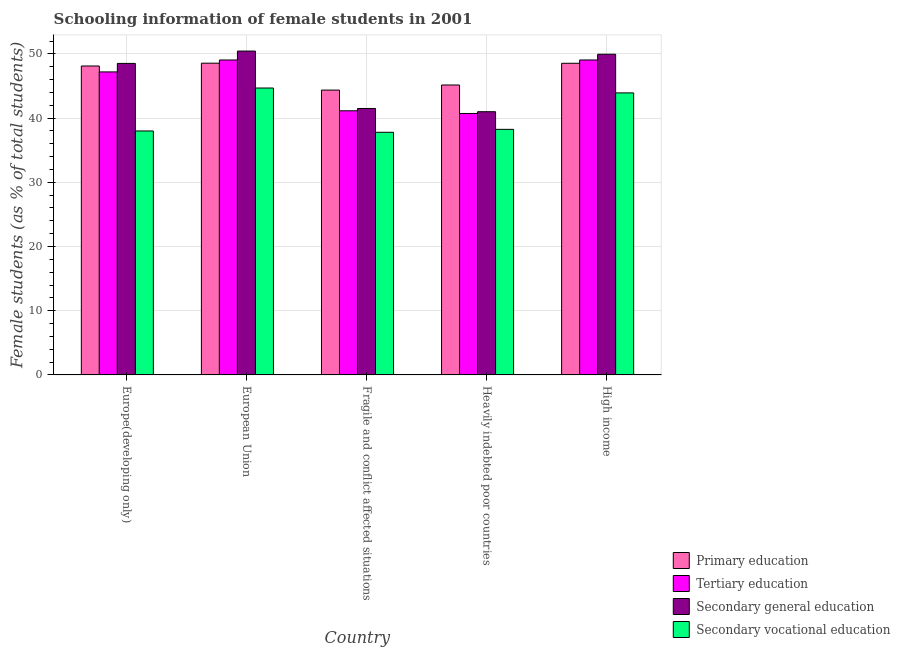How many groups of bars are there?
Keep it short and to the point. 5. Are the number of bars per tick equal to the number of legend labels?
Ensure brevity in your answer.  Yes. How many bars are there on the 1st tick from the left?
Offer a terse response. 4. How many bars are there on the 1st tick from the right?
Offer a terse response. 4. What is the label of the 1st group of bars from the left?
Your answer should be compact. Europe(developing only). In how many cases, is the number of bars for a given country not equal to the number of legend labels?
Make the answer very short. 0. What is the percentage of female students in tertiary education in High income?
Provide a succinct answer. 49.05. Across all countries, what is the maximum percentage of female students in primary education?
Ensure brevity in your answer.  48.55. Across all countries, what is the minimum percentage of female students in secondary vocational education?
Your answer should be very brief. 37.78. In which country was the percentage of female students in secondary vocational education maximum?
Your response must be concise. European Union. In which country was the percentage of female students in secondary vocational education minimum?
Your answer should be compact. Fragile and conflict affected situations. What is the total percentage of female students in secondary education in the graph?
Give a very brief answer. 231.37. What is the difference between the percentage of female students in secondary vocational education in Fragile and conflict affected situations and that in Heavily indebted poor countries?
Your answer should be compact. -0.46. What is the difference between the percentage of female students in tertiary education in Fragile and conflict affected situations and the percentage of female students in primary education in Europe(developing only)?
Make the answer very short. -6.98. What is the average percentage of female students in secondary education per country?
Your answer should be very brief. 46.27. What is the difference between the percentage of female students in tertiary education and percentage of female students in primary education in Heavily indebted poor countries?
Provide a short and direct response. -4.43. What is the ratio of the percentage of female students in secondary vocational education in Fragile and conflict affected situations to that in Heavily indebted poor countries?
Your answer should be very brief. 0.99. What is the difference between the highest and the second highest percentage of female students in primary education?
Give a very brief answer. 0.02. What is the difference between the highest and the lowest percentage of female students in tertiary education?
Provide a succinct answer. 8.33. In how many countries, is the percentage of female students in secondary education greater than the average percentage of female students in secondary education taken over all countries?
Make the answer very short. 3. What does the 4th bar from the left in Europe(developing only) represents?
Offer a terse response. Secondary vocational education. What does the 3rd bar from the right in European Union represents?
Provide a succinct answer. Tertiary education. How many countries are there in the graph?
Offer a terse response. 5. What is the difference between two consecutive major ticks on the Y-axis?
Your response must be concise. 10. How many legend labels are there?
Offer a terse response. 4. How are the legend labels stacked?
Give a very brief answer. Vertical. What is the title of the graph?
Provide a succinct answer. Schooling information of female students in 2001. What is the label or title of the X-axis?
Your answer should be compact. Country. What is the label or title of the Y-axis?
Offer a very short reply. Female students (as % of total students). What is the Female students (as % of total students) in Primary education in Europe(developing only)?
Your response must be concise. 48.11. What is the Female students (as % of total students) of Tertiary education in Europe(developing only)?
Your answer should be compact. 47.19. What is the Female students (as % of total students) in Secondary general education in Europe(developing only)?
Offer a terse response. 48.51. What is the Female students (as % of total students) of Secondary vocational education in Europe(developing only)?
Keep it short and to the point. 37.99. What is the Female students (as % of total students) in Primary education in European Union?
Give a very brief answer. 48.55. What is the Female students (as % of total students) of Tertiary education in European Union?
Your answer should be compact. 49.04. What is the Female students (as % of total students) of Secondary general education in European Union?
Provide a short and direct response. 50.43. What is the Female students (as % of total students) in Secondary vocational education in European Union?
Your answer should be compact. 44.68. What is the Female students (as % of total students) in Primary education in Fragile and conflict affected situations?
Offer a very short reply. 44.36. What is the Female students (as % of total students) in Tertiary education in Fragile and conflict affected situations?
Provide a succinct answer. 41.13. What is the Female students (as % of total students) of Secondary general education in Fragile and conflict affected situations?
Your answer should be very brief. 41.49. What is the Female students (as % of total students) of Secondary vocational education in Fragile and conflict affected situations?
Your response must be concise. 37.78. What is the Female students (as % of total students) of Primary education in Heavily indebted poor countries?
Offer a terse response. 45.15. What is the Female students (as % of total students) of Tertiary education in Heavily indebted poor countries?
Your response must be concise. 40.71. What is the Female students (as % of total students) in Secondary general education in Heavily indebted poor countries?
Your answer should be very brief. 40.99. What is the Female students (as % of total students) in Secondary vocational education in Heavily indebted poor countries?
Give a very brief answer. 38.24. What is the Female students (as % of total students) in Primary education in High income?
Keep it short and to the point. 48.53. What is the Female students (as % of total students) of Tertiary education in High income?
Ensure brevity in your answer.  49.05. What is the Female students (as % of total students) in Secondary general education in High income?
Your answer should be very brief. 49.94. What is the Female students (as % of total students) of Secondary vocational education in High income?
Your response must be concise. 43.92. Across all countries, what is the maximum Female students (as % of total students) of Primary education?
Offer a terse response. 48.55. Across all countries, what is the maximum Female students (as % of total students) in Tertiary education?
Your answer should be very brief. 49.05. Across all countries, what is the maximum Female students (as % of total students) of Secondary general education?
Provide a succinct answer. 50.43. Across all countries, what is the maximum Female students (as % of total students) in Secondary vocational education?
Give a very brief answer. 44.68. Across all countries, what is the minimum Female students (as % of total students) of Primary education?
Ensure brevity in your answer.  44.36. Across all countries, what is the minimum Female students (as % of total students) in Tertiary education?
Provide a succinct answer. 40.71. Across all countries, what is the minimum Female students (as % of total students) in Secondary general education?
Keep it short and to the point. 40.99. Across all countries, what is the minimum Female students (as % of total students) of Secondary vocational education?
Provide a succinct answer. 37.78. What is the total Female students (as % of total students) in Primary education in the graph?
Your response must be concise. 234.69. What is the total Female students (as % of total students) in Tertiary education in the graph?
Give a very brief answer. 227.12. What is the total Female students (as % of total students) of Secondary general education in the graph?
Ensure brevity in your answer.  231.37. What is the total Female students (as % of total students) in Secondary vocational education in the graph?
Your answer should be compact. 202.61. What is the difference between the Female students (as % of total students) of Primary education in Europe(developing only) and that in European Union?
Ensure brevity in your answer.  -0.44. What is the difference between the Female students (as % of total students) in Tertiary education in Europe(developing only) and that in European Union?
Give a very brief answer. -1.86. What is the difference between the Female students (as % of total students) in Secondary general education in Europe(developing only) and that in European Union?
Keep it short and to the point. -1.92. What is the difference between the Female students (as % of total students) in Secondary vocational education in Europe(developing only) and that in European Union?
Your response must be concise. -6.69. What is the difference between the Female students (as % of total students) in Primary education in Europe(developing only) and that in Fragile and conflict affected situations?
Keep it short and to the point. 3.75. What is the difference between the Female students (as % of total students) in Tertiary education in Europe(developing only) and that in Fragile and conflict affected situations?
Provide a short and direct response. 6.05. What is the difference between the Female students (as % of total students) in Secondary general education in Europe(developing only) and that in Fragile and conflict affected situations?
Keep it short and to the point. 7.02. What is the difference between the Female students (as % of total students) in Secondary vocational education in Europe(developing only) and that in Fragile and conflict affected situations?
Offer a terse response. 0.21. What is the difference between the Female students (as % of total students) of Primary education in Europe(developing only) and that in Heavily indebted poor countries?
Your answer should be very brief. 2.96. What is the difference between the Female students (as % of total students) of Tertiary education in Europe(developing only) and that in Heavily indebted poor countries?
Provide a succinct answer. 6.47. What is the difference between the Female students (as % of total students) of Secondary general education in Europe(developing only) and that in Heavily indebted poor countries?
Keep it short and to the point. 7.52. What is the difference between the Female students (as % of total students) of Secondary vocational education in Europe(developing only) and that in Heavily indebted poor countries?
Your answer should be very brief. -0.25. What is the difference between the Female students (as % of total students) in Primary education in Europe(developing only) and that in High income?
Your answer should be compact. -0.42. What is the difference between the Female students (as % of total students) in Tertiary education in Europe(developing only) and that in High income?
Provide a succinct answer. -1.86. What is the difference between the Female students (as % of total students) in Secondary general education in Europe(developing only) and that in High income?
Make the answer very short. -1.43. What is the difference between the Female students (as % of total students) of Secondary vocational education in Europe(developing only) and that in High income?
Your answer should be very brief. -5.93. What is the difference between the Female students (as % of total students) of Primary education in European Union and that in Fragile and conflict affected situations?
Ensure brevity in your answer.  4.19. What is the difference between the Female students (as % of total students) of Tertiary education in European Union and that in Fragile and conflict affected situations?
Provide a short and direct response. 7.91. What is the difference between the Female students (as % of total students) in Secondary general education in European Union and that in Fragile and conflict affected situations?
Offer a very short reply. 8.94. What is the difference between the Female students (as % of total students) of Secondary vocational education in European Union and that in Fragile and conflict affected situations?
Provide a short and direct response. 6.89. What is the difference between the Female students (as % of total students) in Primary education in European Union and that in Heavily indebted poor countries?
Your response must be concise. 3.4. What is the difference between the Female students (as % of total students) of Tertiary education in European Union and that in Heavily indebted poor countries?
Offer a terse response. 8.33. What is the difference between the Female students (as % of total students) of Secondary general education in European Union and that in Heavily indebted poor countries?
Provide a succinct answer. 9.44. What is the difference between the Female students (as % of total students) of Secondary vocational education in European Union and that in Heavily indebted poor countries?
Offer a terse response. 6.44. What is the difference between the Female students (as % of total students) in Primary education in European Union and that in High income?
Your response must be concise. 0.02. What is the difference between the Female students (as % of total students) of Tertiary education in European Union and that in High income?
Provide a succinct answer. -0. What is the difference between the Female students (as % of total students) of Secondary general education in European Union and that in High income?
Your response must be concise. 0.49. What is the difference between the Female students (as % of total students) of Secondary vocational education in European Union and that in High income?
Offer a terse response. 0.76. What is the difference between the Female students (as % of total students) of Primary education in Fragile and conflict affected situations and that in Heavily indebted poor countries?
Give a very brief answer. -0.79. What is the difference between the Female students (as % of total students) in Tertiary education in Fragile and conflict affected situations and that in Heavily indebted poor countries?
Make the answer very short. 0.42. What is the difference between the Female students (as % of total students) in Secondary general education in Fragile and conflict affected situations and that in Heavily indebted poor countries?
Provide a short and direct response. 0.5. What is the difference between the Female students (as % of total students) of Secondary vocational education in Fragile and conflict affected situations and that in Heavily indebted poor countries?
Your answer should be compact. -0.46. What is the difference between the Female students (as % of total students) in Primary education in Fragile and conflict affected situations and that in High income?
Provide a short and direct response. -4.17. What is the difference between the Female students (as % of total students) in Tertiary education in Fragile and conflict affected situations and that in High income?
Offer a terse response. -7.91. What is the difference between the Female students (as % of total students) of Secondary general education in Fragile and conflict affected situations and that in High income?
Offer a terse response. -8.45. What is the difference between the Female students (as % of total students) of Secondary vocational education in Fragile and conflict affected situations and that in High income?
Provide a short and direct response. -6.13. What is the difference between the Female students (as % of total students) of Primary education in Heavily indebted poor countries and that in High income?
Provide a succinct answer. -3.38. What is the difference between the Female students (as % of total students) in Tertiary education in Heavily indebted poor countries and that in High income?
Offer a very short reply. -8.33. What is the difference between the Female students (as % of total students) of Secondary general education in Heavily indebted poor countries and that in High income?
Make the answer very short. -8.95. What is the difference between the Female students (as % of total students) of Secondary vocational education in Heavily indebted poor countries and that in High income?
Give a very brief answer. -5.68. What is the difference between the Female students (as % of total students) in Primary education in Europe(developing only) and the Female students (as % of total students) in Tertiary education in European Union?
Offer a very short reply. -0.93. What is the difference between the Female students (as % of total students) of Primary education in Europe(developing only) and the Female students (as % of total students) of Secondary general education in European Union?
Keep it short and to the point. -2.32. What is the difference between the Female students (as % of total students) in Primary education in Europe(developing only) and the Female students (as % of total students) in Secondary vocational education in European Union?
Your response must be concise. 3.43. What is the difference between the Female students (as % of total students) in Tertiary education in Europe(developing only) and the Female students (as % of total students) in Secondary general education in European Union?
Provide a short and direct response. -3.25. What is the difference between the Female students (as % of total students) in Tertiary education in Europe(developing only) and the Female students (as % of total students) in Secondary vocational education in European Union?
Make the answer very short. 2.51. What is the difference between the Female students (as % of total students) of Secondary general education in Europe(developing only) and the Female students (as % of total students) of Secondary vocational education in European Union?
Provide a short and direct response. 3.83. What is the difference between the Female students (as % of total students) in Primary education in Europe(developing only) and the Female students (as % of total students) in Tertiary education in Fragile and conflict affected situations?
Your response must be concise. 6.98. What is the difference between the Female students (as % of total students) in Primary education in Europe(developing only) and the Female students (as % of total students) in Secondary general education in Fragile and conflict affected situations?
Provide a short and direct response. 6.62. What is the difference between the Female students (as % of total students) in Primary education in Europe(developing only) and the Female students (as % of total students) in Secondary vocational education in Fragile and conflict affected situations?
Keep it short and to the point. 10.32. What is the difference between the Female students (as % of total students) in Tertiary education in Europe(developing only) and the Female students (as % of total students) in Secondary general education in Fragile and conflict affected situations?
Your response must be concise. 5.69. What is the difference between the Female students (as % of total students) of Tertiary education in Europe(developing only) and the Female students (as % of total students) of Secondary vocational education in Fragile and conflict affected situations?
Keep it short and to the point. 9.4. What is the difference between the Female students (as % of total students) in Secondary general education in Europe(developing only) and the Female students (as % of total students) in Secondary vocational education in Fragile and conflict affected situations?
Ensure brevity in your answer.  10.73. What is the difference between the Female students (as % of total students) of Primary education in Europe(developing only) and the Female students (as % of total students) of Tertiary education in Heavily indebted poor countries?
Your answer should be compact. 7.39. What is the difference between the Female students (as % of total students) in Primary education in Europe(developing only) and the Female students (as % of total students) in Secondary general education in Heavily indebted poor countries?
Offer a terse response. 7.12. What is the difference between the Female students (as % of total students) of Primary education in Europe(developing only) and the Female students (as % of total students) of Secondary vocational education in Heavily indebted poor countries?
Ensure brevity in your answer.  9.87. What is the difference between the Female students (as % of total students) in Tertiary education in Europe(developing only) and the Female students (as % of total students) in Secondary general education in Heavily indebted poor countries?
Your response must be concise. 6.2. What is the difference between the Female students (as % of total students) of Tertiary education in Europe(developing only) and the Female students (as % of total students) of Secondary vocational education in Heavily indebted poor countries?
Keep it short and to the point. 8.94. What is the difference between the Female students (as % of total students) of Secondary general education in Europe(developing only) and the Female students (as % of total students) of Secondary vocational education in Heavily indebted poor countries?
Provide a succinct answer. 10.27. What is the difference between the Female students (as % of total students) of Primary education in Europe(developing only) and the Female students (as % of total students) of Tertiary education in High income?
Offer a very short reply. -0.94. What is the difference between the Female students (as % of total students) of Primary education in Europe(developing only) and the Female students (as % of total students) of Secondary general education in High income?
Your response must be concise. -1.83. What is the difference between the Female students (as % of total students) of Primary education in Europe(developing only) and the Female students (as % of total students) of Secondary vocational education in High income?
Provide a succinct answer. 4.19. What is the difference between the Female students (as % of total students) in Tertiary education in Europe(developing only) and the Female students (as % of total students) in Secondary general education in High income?
Provide a short and direct response. -2.75. What is the difference between the Female students (as % of total students) of Tertiary education in Europe(developing only) and the Female students (as % of total students) of Secondary vocational education in High income?
Offer a terse response. 3.27. What is the difference between the Female students (as % of total students) in Secondary general education in Europe(developing only) and the Female students (as % of total students) in Secondary vocational education in High income?
Ensure brevity in your answer.  4.59. What is the difference between the Female students (as % of total students) of Primary education in European Union and the Female students (as % of total students) of Tertiary education in Fragile and conflict affected situations?
Your response must be concise. 7.41. What is the difference between the Female students (as % of total students) of Primary education in European Union and the Female students (as % of total students) of Secondary general education in Fragile and conflict affected situations?
Offer a terse response. 7.06. What is the difference between the Female students (as % of total students) in Primary education in European Union and the Female students (as % of total students) in Secondary vocational education in Fragile and conflict affected situations?
Provide a succinct answer. 10.76. What is the difference between the Female students (as % of total students) of Tertiary education in European Union and the Female students (as % of total students) of Secondary general education in Fragile and conflict affected situations?
Your answer should be compact. 7.55. What is the difference between the Female students (as % of total students) in Tertiary education in European Union and the Female students (as % of total students) in Secondary vocational education in Fragile and conflict affected situations?
Provide a short and direct response. 11.26. What is the difference between the Female students (as % of total students) in Secondary general education in European Union and the Female students (as % of total students) in Secondary vocational education in Fragile and conflict affected situations?
Provide a succinct answer. 12.65. What is the difference between the Female students (as % of total students) in Primary education in European Union and the Female students (as % of total students) in Tertiary education in Heavily indebted poor countries?
Your answer should be compact. 7.83. What is the difference between the Female students (as % of total students) of Primary education in European Union and the Female students (as % of total students) of Secondary general education in Heavily indebted poor countries?
Ensure brevity in your answer.  7.56. What is the difference between the Female students (as % of total students) in Primary education in European Union and the Female students (as % of total students) in Secondary vocational education in Heavily indebted poor countries?
Make the answer very short. 10.31. What is the difference between the Female students (as % of total students) of Tertiary education in European Union and the Female students (as % of total students) of Secondary general education in Heavily indebted poor countries?
Provide a short and direct response. 8.05. What is the difference between the Female students (as % of total students) in Tertiary education in European Union and the Female students (as % of total students) in Secondary vocational education in Heavily indebted poor countries?
Your answer should be compact. 10.8. What is the difference between the Female students (as % of total students) of Secondary general education in European Union and the Female students (as % of total students) of Secondary vocational education in Heavily indebted poor countries?
Provide a succinct answer. 12.19. What is the difference between the Female students (as % of total students) of Primary education in European Union and the Female students (as % of total students) of Tertiary education in High income?
Give a very brief answer. -0.5. What is the difference between the Female students (as % of total students) of Primary education in European Union and the Female students (as % of total students) of Secondary general education in High income?
Keep it short and to the point. -1.39. What is the difference between the Female students (as % of total students) in Primary education in European Union and the Female students (as % of total students) in Secondary vocational education in High income?
Your answer should be compact. 4.63. What is the difference between the Female students (as % of total students) in Tertiary education in European Union and the Female students (as % of total students) in Secondary general education in High income?
Offer a terse response. -0.9. What is the difference between the Female students (as % of total students) in Tertiary education in European Union and the Female students (as % of total students) in Secondary vocational education in High income?
Your answer should be compact. 5.12. What is the difference between the Female students (as % of total students) in Secondary general education in European Union and the Female students (as % of total students) in Secondary vocational education in High income?
Your answer should be very brief. 6.51. What is the difference between the Female students (as % of total students) in Primary education in Fragile and conflict affected situations and the Female students (as % of total students) in Tertiary education in Heavily indebted poor countries?
Provide a succinct answer. 3.64. What is the difference between the Female students (as % of total students) of Primary education in Fragile and conflict affected situations and the Female students (as % of total students) of Secondary general education in Heavily indebted poor countries?
Give a very brief answer. 3.37. What is the difference between the Female students (as % of total students) in Primary education in Fragile and conflict affected situations and the Female students (as % of total students) in Secondary vocational education in Heavily indebted poor countries?
Give a very brief answer. 6.12. What is the difference between the Female students (as % of total students) of Tertiary education in Fragile and conflict affected situations and the Female students (as % of total students) of Secondary general education in Heavily indebted poor countries?
Offer a very short reply. 0.14. What is the difference between the Female students (as % of total students) of Tertiary education in Fragile and conflict affected situations and the Female students (as % of total students) of Secondary vocational education in Heavily indebted poor countries?
Your answer should be very brief. 2.89. What is the difference between the Female students (as % of total students) of Secondary general education in Fragile and conflict affected situations and the Female students (as % of total students) of Secondary vocational education in Heavily indebted poor countries?
Your answer should be compact. 3.25. What is the difference between the Female students (as % of total students) of Primary education in Fragile and conflict affected situations and the Female students (as % of total students) of Tertiary education in High income?
Offer a terse response. -4.69. What is the difference between the Female students (as % of total students) in Primary education in Fragile and conflict affected situations and the Female students (as % of total students) in Secondary general education in High income?
Ensure brevity in your answer.  -5.58. What is the difference between the Female students (as % of total students) in Primary education in Fragile and conflict affected situations and the Female students (as % of total students) in Secondary vocational education in High income?
Offer a very short reply. 0.44. What is the difference between the Female students (as % of total students) of Tertiary education in Fragile and conflict affected situations and the Female students (as % of total students) of Secondary general education in High income?
Make the answer very short. -8.81. What is the difference between the Female students (as % of total students) in Tertiary education in Fragile and conflict affected situations and the Female students (as % of total students) in Secondary vocational education in High income?
Provide a short and direct response. -2.79. What is the difference between the Female students (as % of total students) in Secondary general education in Fragile and conflict affected situations and the Female students (as % of total students) in Secondary vocational education in High income?
Ensure brevity in your answer.  -2.43. What is the difference between the Female students (as % of total students) of Primary education in Heavily indebted poor countries and the Female students (as % of total students) of Tertiary education in High income?
Offer a very short reply. -3.9. What is the difference between the Female students (as % of total students) of Primary education in Heavily indebted poor countries and the Female students (as % of total students) of Secondary general education in High income?
Provide a succinct answer. -4.79. What is the difference between the Female students (as % of total students) in Primary education in Heavily indebted poor countries and the Female students (as % of total students) in Secondary vocational education in High income?
Ensure brevity in your answer.  1.23. What is the difference between the Female students (as % of total students) in Tertiary education in Heavily indebted poor countries and the Female students (as % of total students) in Secondary general education in High income?
Give a very brief answer. -9.23. What is the difference between the Female students (as % of total students) of Tertiary education in Heavily indebted poor countries and the Female students (as % of total students) of Secondary vocational education in High income?
Offer a terse response. -3.2. What is the difference between the Female students (as % of total students) of Secondary general education in Heavily indebted poor countries and the Female students (as % of total students) of Secondary vocational education in High income?
Make the answer very short. -2.93. What is the average Female students (as % of total students) in Primary education per country?
Offer a very short reply. 46.94. What is the average Female students (as % of total students) in Tertiary education per country?
Offer a very short reply. 45.42. What is the average Female students (as % of total students) of Secondary general education per country?
Your response must be concise. 46.27. What is the average Female students (as % of total students) in Secondary vocational education per country?
Make the answer very short. 40.52. What is the difference between the Female students (as % of total students) in Primary education and Female students (as % of total students) in Tertiary education in Europe(developing only)?
Provide a succinct answer. 0.92. What is the difference between the Female students (as % of total students) of Primary education and Female students (as % of total students) of Secondary general education in Europe(developing only)?
Keep it short and to the point. -0.4. What is the difference between the Female students (as % of total students) of Primary education and Female students (as % of total students) of Secondary vocational education in Europe(developing only)?
Your answer should be compact. 10.12. What is the difference between the Female students (as % of total students) in Tertiary education and Female students (as % of total students) in Secondary general education in Europe(developing only)?
Your response must be concise. -1.33. What is the difference between the Female students (as % of total students) in Tertiary education and Female students (as % of total students) in Secondary vocational education in Europe(developing only)?
Keep it short and to the point. 9.2. What is the difference between the Female students (as % of total students) in Secondary general education and Female students (as % of total students) in Secondary vocational education in Europe(developing only)?
Give a very brief answer. 10.52. What is the difference between the Female students (as % of total students) in Primary education and Female students (as % of total students) in Tertiary education in European Union?
Ensure brevity in your answer.  -0.5. What is the difference between the Female students (as % of total students) of Primary education and Female students (as % of total students) of Secondary general education in European Union?
Keep it short and to the point. -1.89. What is the difference between the Female students (as % of total students) of Primary education and Female students (as % of total students) of Secondary vocational education in European Union?
Make the answer very short. 3.87. What is the difference between the Female students (as % of total students) in Tertiary education and Female students (as % of total students) in Secondary general education in European Union?
Give a very brief answer. -1.39. What is the difference between the Female students (as % of total students) in Tertiary education and Female students (as % of total students) in Secondary vocational education in European Union?
Your answer should be compact. 4.37. What is the difference between the Female students (as % of total students) of Secondary general education and Female students (as % of total students) of Secondary vocational education in European Union?
Offer a very short reply. 5.76. What is the difference between the Female students (as % of total students) in Primary education and Female students (as % of total students) in Tertiary education in Fragile and conflict affected situations?
Give a very brief answer. 3.22. What is the difference between the Female students (as % of total students) in Primary education and Female students (as % of total students) in Secondary general education in Fragile and conflict affected situations?
Offer a terse response. 2.87. What is the difference between the Female students (as % of total students) in Primary education and Female students (as % of total students) in Secondary vocational education in Fragile and conflict affected situations?
Keep it short and to the point. 6.57. What is the difference between the Female students (as % of total students) in Tertiary education and Female students (as % of total students) in Secondary general education in Fragile and conflict affected situations?
Ensure brevity in your answer.  -0.36. What is the difference between the Female students (as % of total students) of Tertiary education and Female students (as % of total students) of Secondary vocational education in Fragile and conflict affected situations?
Your response must be concise. 3.35. What is the difference between the Female students (as % of total students) in Secondary general education and Female students (as % of total students) in Secondary vocational education in Fragile and conflict affected situations?
Provide a succinct answer. 3.71. What is the difference between the Female students (as % of total students) of Primary education and Female students (as % of total students) of Tertiary education in Heavily indebted poor countries?
Make the answer very short. 4.43. What is the difference between the Female students (as % of total students) of Primary education and Female students (as % of total students) of Secondary general education in Heavily indebted poor countries?
Ensure brevity in your answer.  4.16. What is the difference between the Female students (as % of total students) in Primary education and Female students (as % of total students) in Secondary vocational education in Heavily indebted poor countries?
Ensure brevity in your answer.  6.91. What is the difference between the Female students (as % of total students) in Tertiary education and Female students (as % of total students) in Secondary general education in Heavily indebted poor countries?
Offer a very short reply. -0.27. What is the difference between the Female students (as % of total students) of Tertiary education and Female students (as % of total students) of Secondary vocational education in Heavily indebted poor countries?
Provide a succinct answer. 2.47. What is the difference between the Female students (as % of total students) in Secondary general education and Female students (as % of total students) in Secondary vocational education in Heavily indebted poor countries?
Ensure brevity in your answer.  2.75. What is the difference between the Female students (as % of total students) of Primary education and Female students (as % of total students) of Tertiary education in High income?
Offer a terse response. -0.51. What is the difference between the Female students (as % of total students) in Primary education and Female students (as % of total students) in Secondary general education in High income?
Provide a succinct answer. -1.41. What is the difference between the Female students (as % of total students) in Primary education and Female students (as % of total students) in Secondary vocational education in High income?
Make the answer very short. 4.61. What is the difference between the Female students (as % of total students) in Tertiary education and Female students (as % of total students) in Secondary general education in High income?
Your answer should be compact. -0.89. What is the difference between the Female students (as % of total students) of Tertiary education and Female students (as % of total students) of Secondary vocational education in High income?
Offer a very short reply. 5.13. What is the difference between the Female students (as % of total students) in Secondary general education and Female students (as % of total students) in Secondary vocational education in High income?
Offer a terse response. 6.02. What is the ratio of the Female students (as % of total students) in Primary education in Europe(developing only) to that in European Union?
Your response must be concise. 0.99. What is the ratio of the Female students (as % of total students) of Tertiary education in Europe(developing only) to that in European Union?
Give a very brief answer. 0.96. What is the ratio of the Female students (as % of total students) in Secondary general education in Europe(developing only) to that in European Union?
Give a very brief answer. 0.96. What is the ratio of the Female students (as % of total students) of Secondary vocational education in Europe(developing only) to that in European Union?
Provide a short and direct response. 0.85. What is the ratio of the Female students (as % of total students) in Primary education in Europe(developing only) to that in Fragile and conflict affected situations?
Give a very brief answer. 1.08. What is the ratio of the Female students (as % of total students) in Tertiary education in Europe(developing only) to that in Fragile and conflict affected situations?
Offer a terse response. 1.15. What is the ratio of the Female students (as % of total students) in Secondary general education in Europe(developing only) to that in Fragile and conflict affected situations?
Provide a succinct answer. 1.17. What is the ratio of the Female students (as % of total students) of Secondary vocational education in Europe(developing only) to that in Fragile and conflict affected situations?
Ensure brevity in your answer.  1.01. What is the ratio of the Female students (as % of total students) of Primary education in Europe(developing only) to that in Heavily indebted poor countries?
Your answer should be very brief. 1.07. What is the ratio of the Female students (as % of total students) in Tertiary education in Europe(developing only) to that in Heavily indebted poor countries?
Your response must be concise. 1.16. What is the ratio of the Female students (as % of total students) in Secondary general education in Europe(developing only) to that in Heavily indebted poor countries?
Your response must be concise. 1.18. What is the ratio of the Female students (as % of total students) of Secondary vocational education in Europe(developing only) to that in Heavily indebted poor countries?
Make the answer very short. 0.99. What is the ratio of the Female students (as % of total students) of Tertiary education in Europe(developing only) to that in High income?
Your answer should be very brief. 0.96. What is the ratio of the Female students (as % of total students) in Secondary general education in Europe(developing only) to that in High income?
Your answer should be very brief. 0.97. What is the ratio of the Female students (as % of total students) of Secondary vocational education in Europe(developing only) to that in High income?
Your answer should be very brief. 0.86. What is the ratio of the Female students (as % of total students) in Primary education in European Union to that in Fragile and conflict affected situations?
Ensure brevity in your answer.  1.09. What is the ratio of the Female students (as % of total students) in Tertiary education in European Union to that in Fragile and conflict affected situations?
Offer a terse response. 1.19. What is the ratio of the Female students (as % of total students) in Secondary general education in European Union to that in Fragile and conflict affected situations?
Make the answer very short. 1.22. What is the ratio of the Female students (as % of total students) in Secondary vocational education in European Union to that in Fragile and conflict affected situations?
Keep it short and to the point. 1.18. What is the ratio of the Female students (as % of total students) in Primary education in European Union to that in Heavily indebted poor countries?
Give a very brief answer. 1.08. What is the ratio of the Female students (as % of total students) in Tertiary education in European Union to that in Heavily indebted poor countries?
Offer a very short reply. 1.2. What is the ratio of the Female students (as % of total students) in Secondary general education in European Union to that in Heavily indebted poor countries?
Provide a short and direct response. 1.23. What is the ratio of the Female students (as % of total students) in Secondary vocational education in European Union to that in Heavily indebted poor countries?
Make the answer very short. 1.17. What is the ratio of the Female students (as % of total students) in Secondary general education in European Union to that in High income?
Offer a very short reply. 1.01. What is the ratio of the Female students (as % of total students) in Secondary vocational education in European Union to that in High income?
Offer a very short reply. 1.02. What is the ratio of the Female students (as % of total students) of Primary education in Fragile and conflict affected situations to that in Heavily indebted poor countries?
Offer a terse response. 0.98. What is the ratio of the Female students (as % of total students) of Tertiary education in Fragile and conflict affected situations to that in Heavily indebted poor countries?
Give a very brief answer. 1.01. What is the ratio of the Female students (as % of total students) of Secondary general education in Fragile and conflict affected situations to that in Heavily indebted poor countries?
Offer a very short reply. 1.01. What is the ratio of the Female students (as % of total students) in Primary education in Fragile and conflict affected situations to that in High income?
Offer a very short reply. 0.91. What is the ratio of the Female students (as % of total students) in Tertiary education in Fragile and conflict affected situations to that in High income?
Keep it short and to the point. 0.84. What is the ratio of the Female students (as % of total students) of Secondary general education in Fragile and conflict affected situations to that in High income?
Your answer should be very brief. 0.83. What is the ratio of the Female students (as % of total students) in Secondary vocational education in Fragile and conflict affected situations to that in High income?
Ensure brevity in your answer.  0.86. What is the ratio of the Female students (as % of total students) of Primary education in Heavily indebted poor countries to that in High income?
Make the answer very short. 0.93. What is the ratio of the Female students (as % of total students) of Tertiary education in Heavily indebted poor countries to that in High income?
Provide a succinct answer. 0.83. What is the ratio of the Female students (as % of total students) of Secondary general education in Heavily indebted poor countries to that in High income?
Your answer should be very brief. 0.82. What is the ratio of the Female students (as % of total students) in Secondary vocational education in Heavily indebted poor countries to that in High income?
Your response must be concise. 0.87. What is the difference between the highest and the second highest Female students (as % of total students) in Primary education?
Offer a terse response. 0.02. What is the difference between the highest and the second highest Female students (as % of total students) of Tertiary education?
Keep it short and to the point. 0. What is the difference between the highest and the second highest Female students (as % of total students) in Secondary general education?
Make the answer very short. 0.49. What is the difference between the highest and the second highest Female students (as % of total students) in Secondary vocational education?
Give a very brief answer. 0.76. What is the difference between the highest and the lowest Female students (as % of total students) in Primary education?
Offer a terse response. 4.19. What is the difference between the highest and the lowest Female students (as % of total students) of Tertiary education?
Give a very brief answer. 8.33. What is the difference between the highest and the lowest Female students (as % of total students) of Secondary general education?
Ensure brevity in your answer.  9.44. What is the difference between the highest and the lowest Female students (as % of total students) of Secondary vocational education?
Provide a succinct answer. 6.89. 